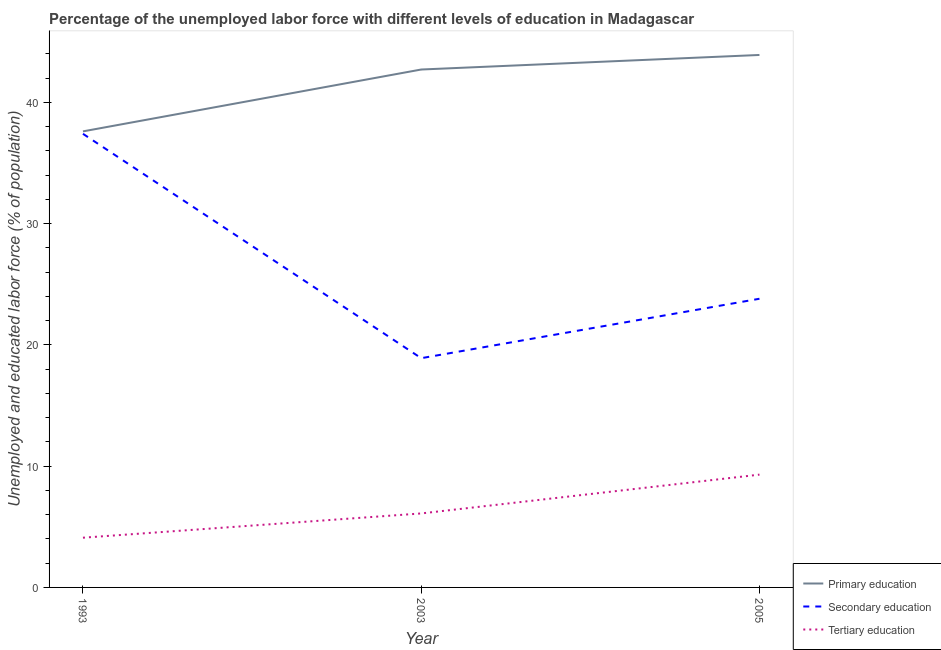Is the number of lines equal to the number of legend labels?
Make the answer very short. Yes. What is the percentage of labor force who received tertiary education in 2005?
Your response must be concise. 9.3. Across all years, what is the maximum percentage of labor force who received tertiary education?
Offer a very short reply. 9.3. Across all years, what is the minimum percentage of labor force who received primary education?
Keep it short and to the point. 37.6. What is the total percentage of labor force who received secondary education in the graph?
Offer a very short reply. 80.1. What is the difference between the percentage of labor force who received tertiary education in 1993 and that in 2005?
Your answer should be very brief. -5.2. What is the difference between the percentage of labor force who received tertiary education in 2005 and the percentage of labor force who received primary education in 2003?
Your answer should be compact. -33.4. What is the average percentage of labor force who received primary education per year?
Ensure brevity in your answer.  41.4. In the year 2003, what is the difference between the percentage of labor force who received secondary education and percentage of labor force who received tertiary education?
Provide a succinct answer. 12.8. In how many years, is the percentage of labor force who received secondary education greater than 40 %?
Your response must be concise. 0. What is the ratio of the percentage of labor force who received secondary education in 1993 to that in 2005?
Provide a succinct answer. 1.57. Is the percentage of labor force who received primary education in 1993 less than that in 2005?
Offer a terse response. Yes. What is the difference between the highest and the second highest percentage of labor force who received tertiary education?
Provide a succinct answer. 3.2. What is the difference between the highest and the lowest percentage of labor force who received secondary education?
Provide a short and direct response. 18.5. In how many years, is the percentage of labor force who received tertiary education greater than the average percentage of labor force who received tertiary education taken over all years?
Give a very brief answer. 1. Is it the case that in every year, the sum of the percentage of labor force who received primary education and percentage of labor force who received secondary education is greater than the percentage of labor force who received tertiary education?
Provide a short and direct response. Yes. Is the percentage of labor force who received primary education strictly greater than the percentage of labor force who received tertiary education over the years?
Make the answer very short. Yes. How many lines are there?
Keep it short and to the point. 3. How many years are there in the graph?
Offer a very short reply. 3. What is the difference between two consecutive major ticks on the Y-axis?
Make the answer very short. 10. Does the graph contain grids?
Offer a terse response. No. Where does the legend appear in the graph?
Make the answer very short. Bottom right. How many legend labels are there?
Your answer should be compact. 3. How are the legend labels stacked?
Provide a short and direct response. Vertical. What is the title of the graph?
Your response must be concise. Percentage of the unemployed labor force with different levels of education in Madagascar. What is the label or title of the Y-axis?
Keep it short and to the point. Unemployed and educated labor force (% of population). What is the Unemployed and educated labor force (% of population) in Primary education in 1993?
Ensure brevity in your answer.  37.6. What is the Unemployed and educated labor force (% of population) of Secondary education in 1993?
Ensure brevity in your answer.  37.4. What is the Unemployed and educated labor force (% of population) of Tertiary education in 1993?
Make the answer very short. 4.1. What is the Unemployed and educated labor force (% of population) in Primary education in 2003?
Your answer should be compact. 42.7. What is the Unemployed and educated labor force (% of population) of Secondary education in 2003?
Offer a terse response. 18.9. What is the Unemployed and educated labor force (% of population) of Tertiary education in 2003?
Provide a succinct answer. 6.1. What is the Unemployed and educated labor force (% of population) in Primary education in 2005?
Offer a very short reply. 43.9. What is the Unemployed and educated labor force (% of population) in Secondary education in 2005?
Make the answer very short. 23.8. What is the Unemployed and educated labor force (% of population) of Tertiary education in 2005?
Your answer should be compact. 9.3. Across all years, what is the maximum Unemployed and educated labor force (% of population) of Primary education?
Ensure brevity in your answer.  43.9. Across all years, what is the maximum Unemployed and educated labor force (% of population) in Secondary education?
Your answer should be compact. 37.4. Across all years, what is the maximum Unemployed and educated labor force (% of population) of Tertiary education?
Offer a very short reply. 9.3. Across all years, what is the minimum Unemployed and educated labor force (% of population) in Primary education?
Make the answer very short. 37.6. Across all years, what is the minimum Unemployed and educated labor force (% of population) in Secondary education?
Provide a succinct answer. 18.9. Across all years, what is the minimum Unemployed and educated labor force (% of population) of Tertiary education?
Make the answer very short. 4.1. What is the total Unemployed and educated labor force (% of population) in Primary education in the graph?
Provide a succinct answer. 124.2. What is the total Unemployed and educated labor force (% of population) of Secondary education in the graph?
Offer a terse response. 80.1. What is the total Unemployed and educated labor force (% of population) in Tertiary education in the graph?
Keep it short and to the point. 19.5. What is the difference between the Unemployed and educated labor force (% of population) of Tertiary education in 1993 and that in 2005?
Your answer should be very brief. -5.2. What is the difference between the Unemployed and educated labor force (% of population) in Primary education in 1993 and the Unemployed and educated labor force (% of population) in Secondary education in 2003?
Give a very brief answer. 18.7. What is the difference between the Unemployed and educated labor force (% of population) in Primary education in 1993 and the Unemployed and educated labor force (% of population) in Tertiary education in 2003?
Keep it short and to the point. 31.5. What is the difference between the Unemployed and educated labor force (% of population) in Secondary education in 1993 and the Unemployed and educated labor force (% of population) in Tertiary education in 2003?
Your answer should be very brief. 31.3. What is the difference between the Unemployed and educated labor force (% of population) of Primary education in 1993 and the Unemployed and educated labor force (% of population) of Tertiary education in 2005?
Offer a very short reply. 28.3. What is the difference between the Unemployed and educated labor force (% of population) in Secondary education in 1993 and the Unemployed and educated labor force (% of population) in Tertiary education in 2005?
Provide a short and direct response. 28.1. What is the difference between the Unemployed and educated labor force (% of population) of Primary education in 2003 and the Unemployed and educated labor force (% of population) of Secondary education in 2005?
Keep it short and to the point. 18.9. What is the difference between the Unemployed and educated labor force (% of population) of Primary education in 2003 and the Unemployed and educated labor force (% of population) of Tertiary education in 2005?
Keep it short and to the point. 33.4. What is the difference between the Unemployed and educated labor force (% of population) of Secondary education in 2003 and the Unemployed and educated labor force (% of population) of Tertiary education in 2005?
Your answer should be compact. 9.6. What is the average Unemployed and educated labor force (% of population) in Primary education per year?
Give a very brief answer. 41.4. What is the average Unemployed and educated labor force (% of population) in Secondary education per year?
Your answer should be very brief. 26.7. What is the average Unemployed and educated labor force (% of population) in Tertiary education per year?
Make the answer very short. 6.5. In the year 1993, what is the difference between the Unemployed and educated labor force (% of population) of Primary education and Unemployed and educated labor force (% of population) of Secondary education?
Offer a terse response. 0.2. In the year 1993, what is the difference between the Unemployed and educated labor force (% of population) of Primary education and Unemployed and educated labor force (% of population) of Tertiary education?
Keep it short and to the point. 33.5. In the year 1993, what is the difference between the Unemployed and educated labor force (% of population) in Secondary education and Unemployed and educated labor force (% of population) in Tertiary education?
Your answer should be compact. 33.3. In the year 2003, what is the difference between the Unemployed and educated labor force (% of population) in Primary education and Unemployed and educated labor force (% of population) in Secondary education?
Provide a succinct answer. 23.8. In the year 2003, what is the difference between the Unemployed and educated labor force (% of population) of Primary education and Unemployed and educated labor force (% of population) of Tertiary education?
Offer a terse response. 36.6. In the year 2005, what is the difference between the Unemployed and educated labor force (% of population) in Primary education and Unemployed and educated labor force (% of population) in Secondary education?
Your response must be concise. 20.1. In the year 2005, what is the difference between the Unemployed and educated labor force (% of population) of Primary education and Unemployed and educated labor force (% of population) of Tertiary education?
Offer a terse response. 34.6. What is the ratio of the Unemployed and educated labor force (% of population) of Primary education in 1993 to that in 2003?
Your answer should be very brief. 0.88. What is the ratio of the Unemployed and educated labor force (% of population) of Secondary education in 1993 to that in 2003?
Ensure brevity in your answer.  1.98. What is the ratio of the Unemployed and educated labor force (% of population) in Tertiary education in 1993 to that in 2003?
Ensure brevity in your answer.  0.67. What is the ratio of the Unemployed and educated labor force (% of population) of Primary education in 1993 to that in 2005?
Your response must be concise. 0.86. What is the ratio of the Unemployed and educated labor force (% of population) in Secondary education in 1993 to that in 2005?
Keep it short and to the point. 1.57. What is the ratio of the Unemployed and educated labor force (% of population) in Tertiary education in 1993 to that in 2005?
Ensure brevity in your answer.  0.44. What is the ratio of the Unemployed and educated labor force (% of population) in Primary education in 2003 to that in 2005?
Offer a very short reply. 0.97. What is the ratio of the Unemployed and educated labor force (% of population) in Secondary education in 2003 to that in 2005?
Your response must be concise. 0.79. What is the ratio of the Unemployed and educated labor force (% of population) of Tertiary education in 2003 to that in 2005?
Keep it short and to the point. 0.66. 